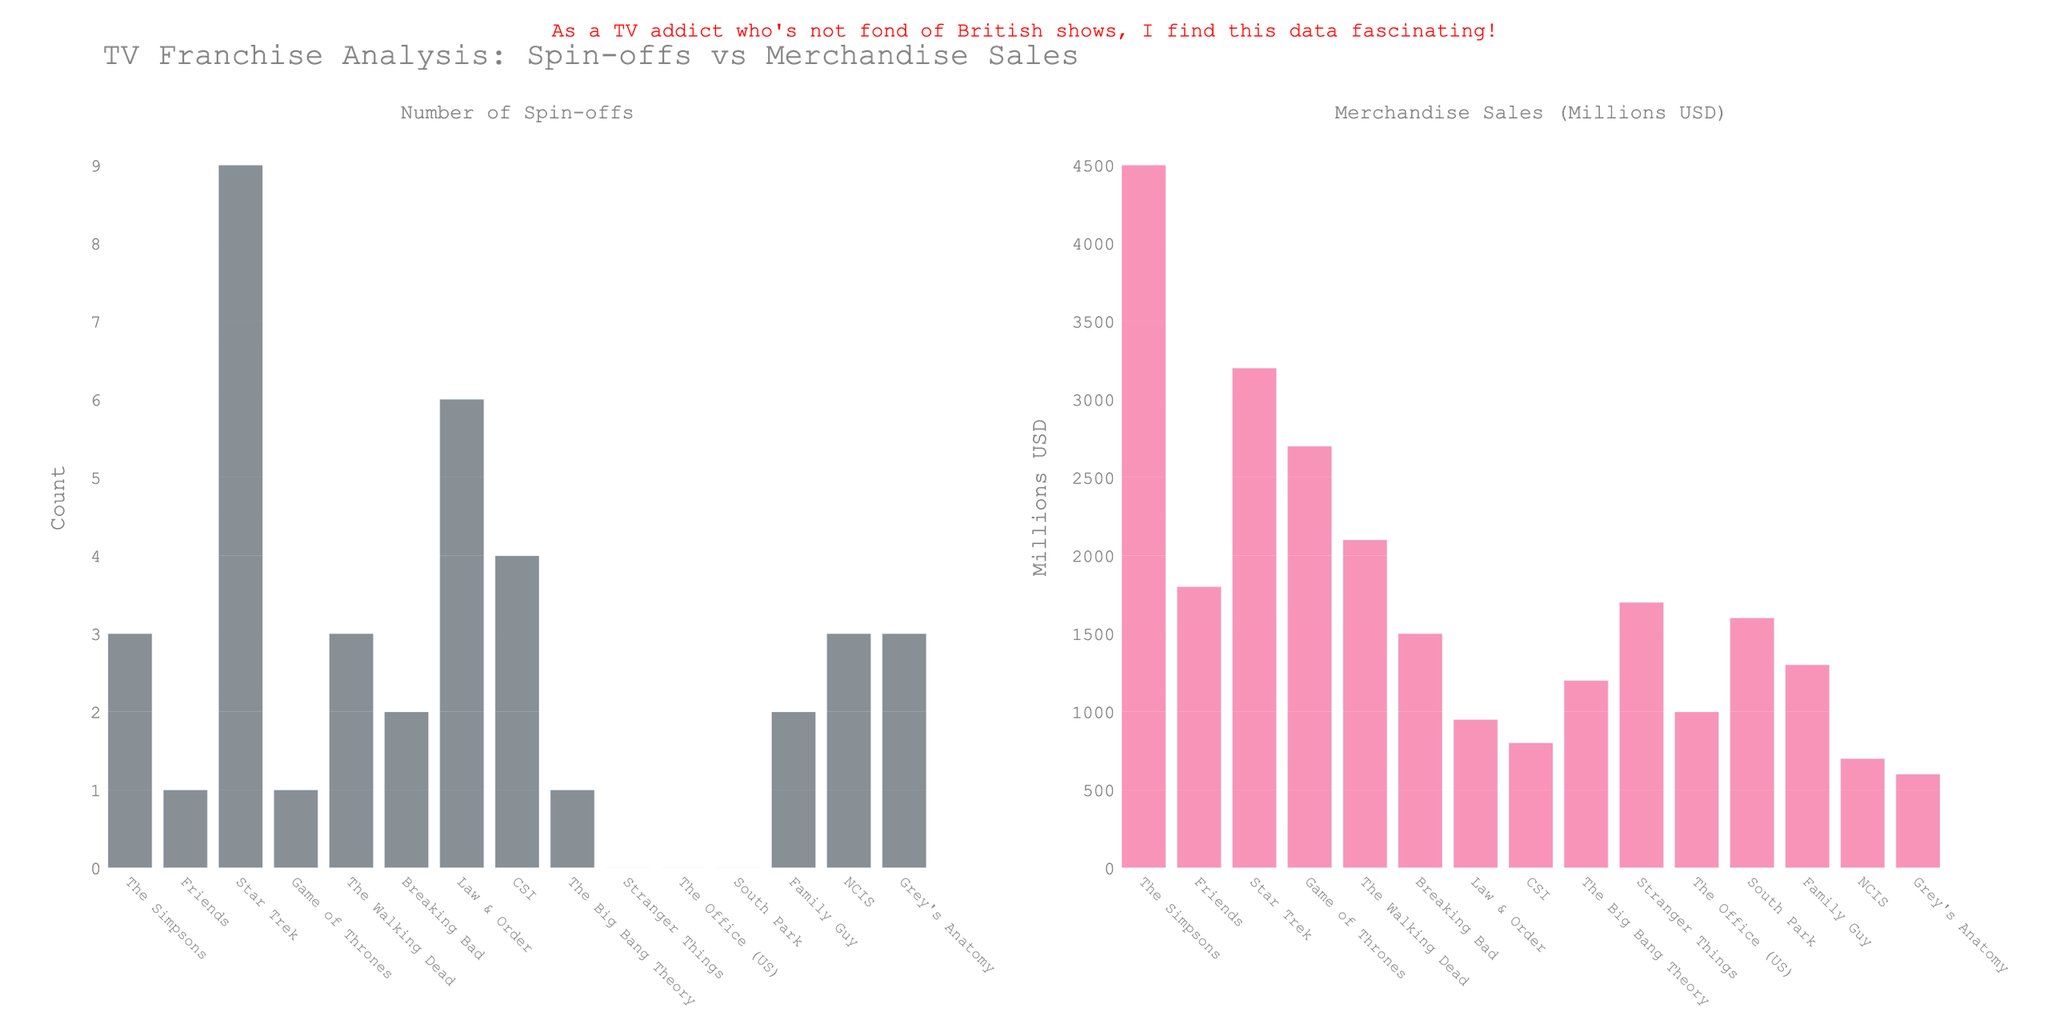Which franchise has the highest merchandise sales? The franchise with the highest merchandise sales can be determined by observing the bar with the greatest height in the second subplot (Merchandise Sales). The highest bar represents "The Simpsons".
Answer: The Simpsons How many more spin-offs does Star Trek have than The Simpsons? To determine the difference in spin-offs between Star Trek and The Simpsons, subtract the number of spin-offs of The Simpsons from Star Trek. Star Trek has 9 spin-offs and The Simpsons has 3, so 9 - 3 = 6.
Answer: 6 Which franchise has the fewest spin-offs, and how is it visually identifiable? The franchise with the fewest spin-offs will have the shortest bar in the first subplot (Number of Spin-offs). Stranger Things, South Park, and The Office (US) all have 0 spin-offs, and their bars are the shortest.
Answer: Stranger Things, South Park, and The Office (US) What is the total merchandise sales for Star Trek and The Big Bang Theory combined? To find the total merchandise sales for Star Trek and The Big Bang Theory combined, add their sales figures. Star Trek has 3200 million USD and The Big Bang Theory has 1200 million USD, so 3200 + 1200 = 4400 million USD.
Answer: 4400 Which franchise has a higher merchandise sales, Breaking Bad or Family Guy, and by how much? To find which franchise has higher merchandise sales between Breaking Bad and Family Guy and the difference, we check the second subplot. Breaking Bad has 1500 million USD and Family Guy has 1300 million USD, so 1500 - 1300 = 200 million USD.
Answer: Breaking Bad by 200 What's the average number of spin-offs for all franchises listed? To find the average number of spin-offs, sum all the spin-offs and divide by the number of franchises. Total spin-offs = 3 + 1 + 9 + 1 + 3 + 2 + 6 + 4 + 1 + 0 + 0 + 0 + 2 + 3 + 3 = 38. Number of franchises = 15. Average = 38 / 15 ≈ 2.53.
Answer: 2.53 Which franchise has a higher number of spin-offs, Law & Order or CSI? To determine which franchise has a higher number of spin-offs, compare the heights of the bars. Law & Order has 6 spin-offs, while CSI has 4 spin-offs.
Answer: Law & Order What is the combined total merchandise sales of Friends, Game of Thrones, and The Walking Dead? To find the combined total merchandise sales, add the sales figures of Friends, Game of Thrones, and The Walking Dead. Friends = 1800, Game of Thrones = 2700, The Walking Dead = 2100. Total = 1800 + 2700 + 2100 = 6600 million USD.
Answer: 6600 Which franchise with 3 spin-offs has the lowest merchandise sales? To determine which franchise with 3 spin-offs has the lowest merchandise sales, look at the first subplot for franchises with 3 spin-offs (The Simpsons, The Walking Dead, NCIS, and Grey's Anatomy). Then, compare their merchandise sales in the second subplot. NCIS has the lowest merchandise sales of 700 million USD.
Answer: NCIS 